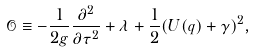Convert formula to latex. <formula><loc_0><loc_0><loc_500><loc_500>\mathcal { O } \equiv - \frac { 1 } { 2 g } \frac { \partial ^ { 2 } } { \partial \tau ^ { 2 } } + \lambda + \frac { 1 } { 2 } ( { U } ( { q } ) + \gamma ) ^ { 2 } ,</formula> 